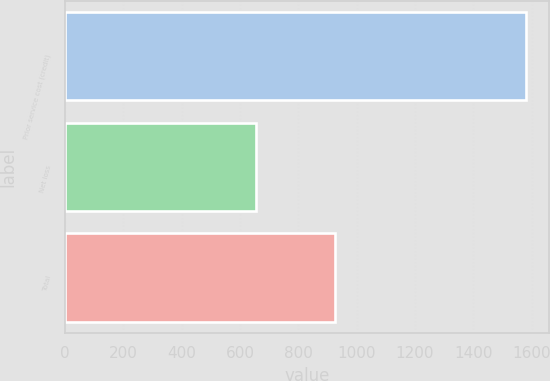Convert chart to OTSL. <chart><loc_0><loc_0><loc_500><loc_500><bar_chart><fcel>Prior service cost (credit)<fcel>Net loss<fcel>Total<nl><fcel>1580<fcel>655<fcel>925<nl></chart> 